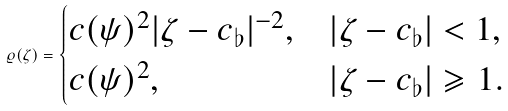Convert formula to latex. <formula><loc_0><loc_0><loc_500><loc_500>\varrho ( \zeta ) = \begin{cases} c ( \psi ) ^ { 2 } | \zeta - c _ { \flat } | ^ { - 2 } , & | \zeta - c _ { \flat } | < 1 , \\ c ( \psi ) ^ { 2 } , & | \zeta - c _ { \flat } | \geqslant 1 . \end{cases}</formula> 